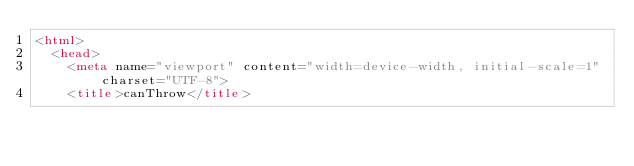<code> <loc_0><loc_0><loc_500><loc_500><_HTML_><html>
  <head>
    <meta name="viewport" content="width=device-width, initial-scale=1" charset="UTF-8">
    <title>canThrow</title></code> 